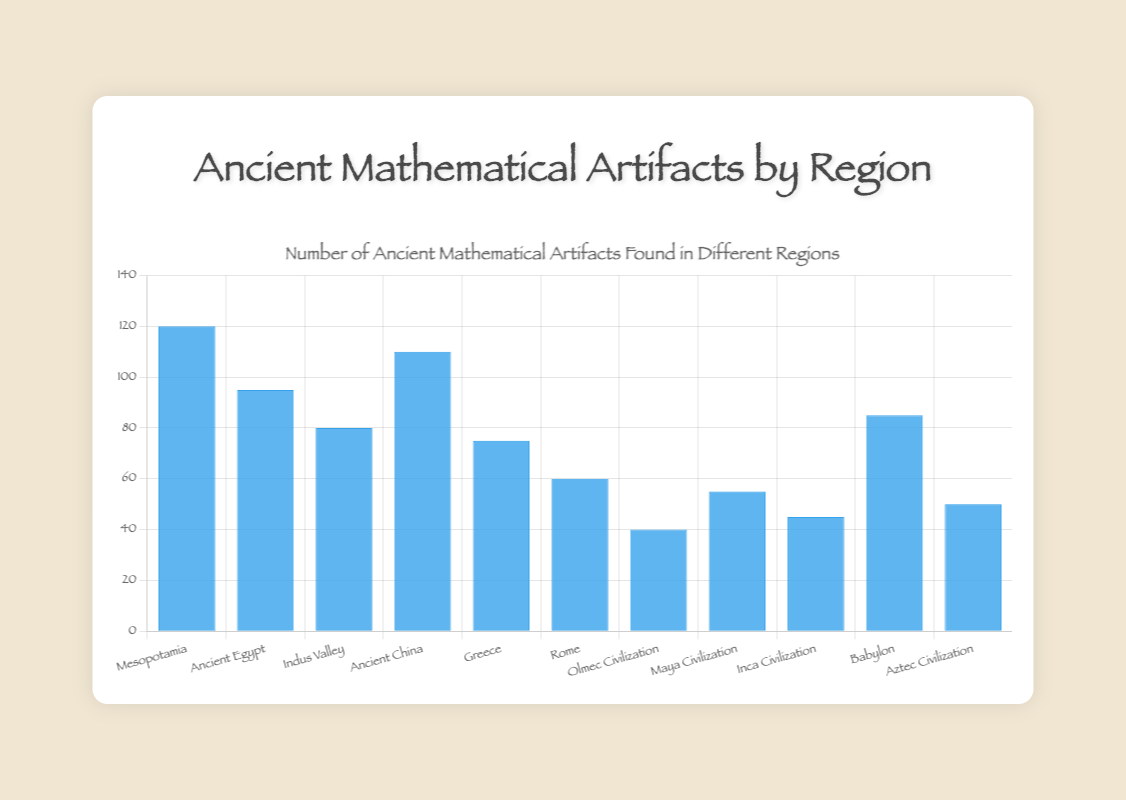Which region has the highest number of ancient mathematical artifacts? The bar representing Mesopotamia is the tallest, indicating it has the highest count of ancient mathematical artifacts at 120.
Answer: Mesopotamia Which regions have fewer than 50 ancient mathematical artifacts? The bars for Olmec Civilization, Aztec Civilization, and Inca Civilization do not reach the 50 mark, indicating they have fewer than 50 artifacts.
Answer: Olmec Civilization, Aztec Civilization, Inca Civilization Which two regions have the closest number of ancient mathematical artifacts? The bars for Maya Civilization and Aztec Civilization are the most similar in height, with artifact counts of 55 and 50 respectively, making their counts the closest.
Answer: Maya Civilization and Aztec Civilization What is the difference in the number of artifacts between Mesopotamia and Ancient China? Mesopotamia has 120 artifacts, and Ancient China has 110. The difference between them is 120 - 110 = 10.
Answer: 10 What is the total number of ancient mathematical artifacts found in Mesopotamia, Ancient China, and Babylon? Sum the artifact counts of Mesopotamia (120), Ancient China (110), and Babylon (85), yielding a total of 120 + 110 + 85 = 315.
Answer: 315 What is the average number of ancient mathematical artifacts found in Greece, Rome, and Maya Civilization? The artifact counts for Greece, Rome, and Maya Civilization are 75, 60, and 55 respectively. The average is (75 + 60 + 55) / 3 = 190 / 3 = ~63.33.
Answer: ~63.33 Which region found exactly 85 ancient mathematical artifacts? By referring to the plot, the bar for Babylon reaches exactly the 85 mark.
Answer: Babylon Is the sum of artifacts found in Indus Valley and Inca Civilization greater than the artifacts found in Greece? Indus Valley has 80 artifacts, and Inca Civilization has 45 artifacts, totaling 80 + 45 = 125. This is greater than Greece's 75 artifacts.
Answer: Yes Which region's artifact count is almost double that of Rome? Rome has 60 artifacts. The bar for Ancient China shows 110 artifacts, which is close to double of 60 (i.e., 120), making it approximately double.
Answer: Ancient China 